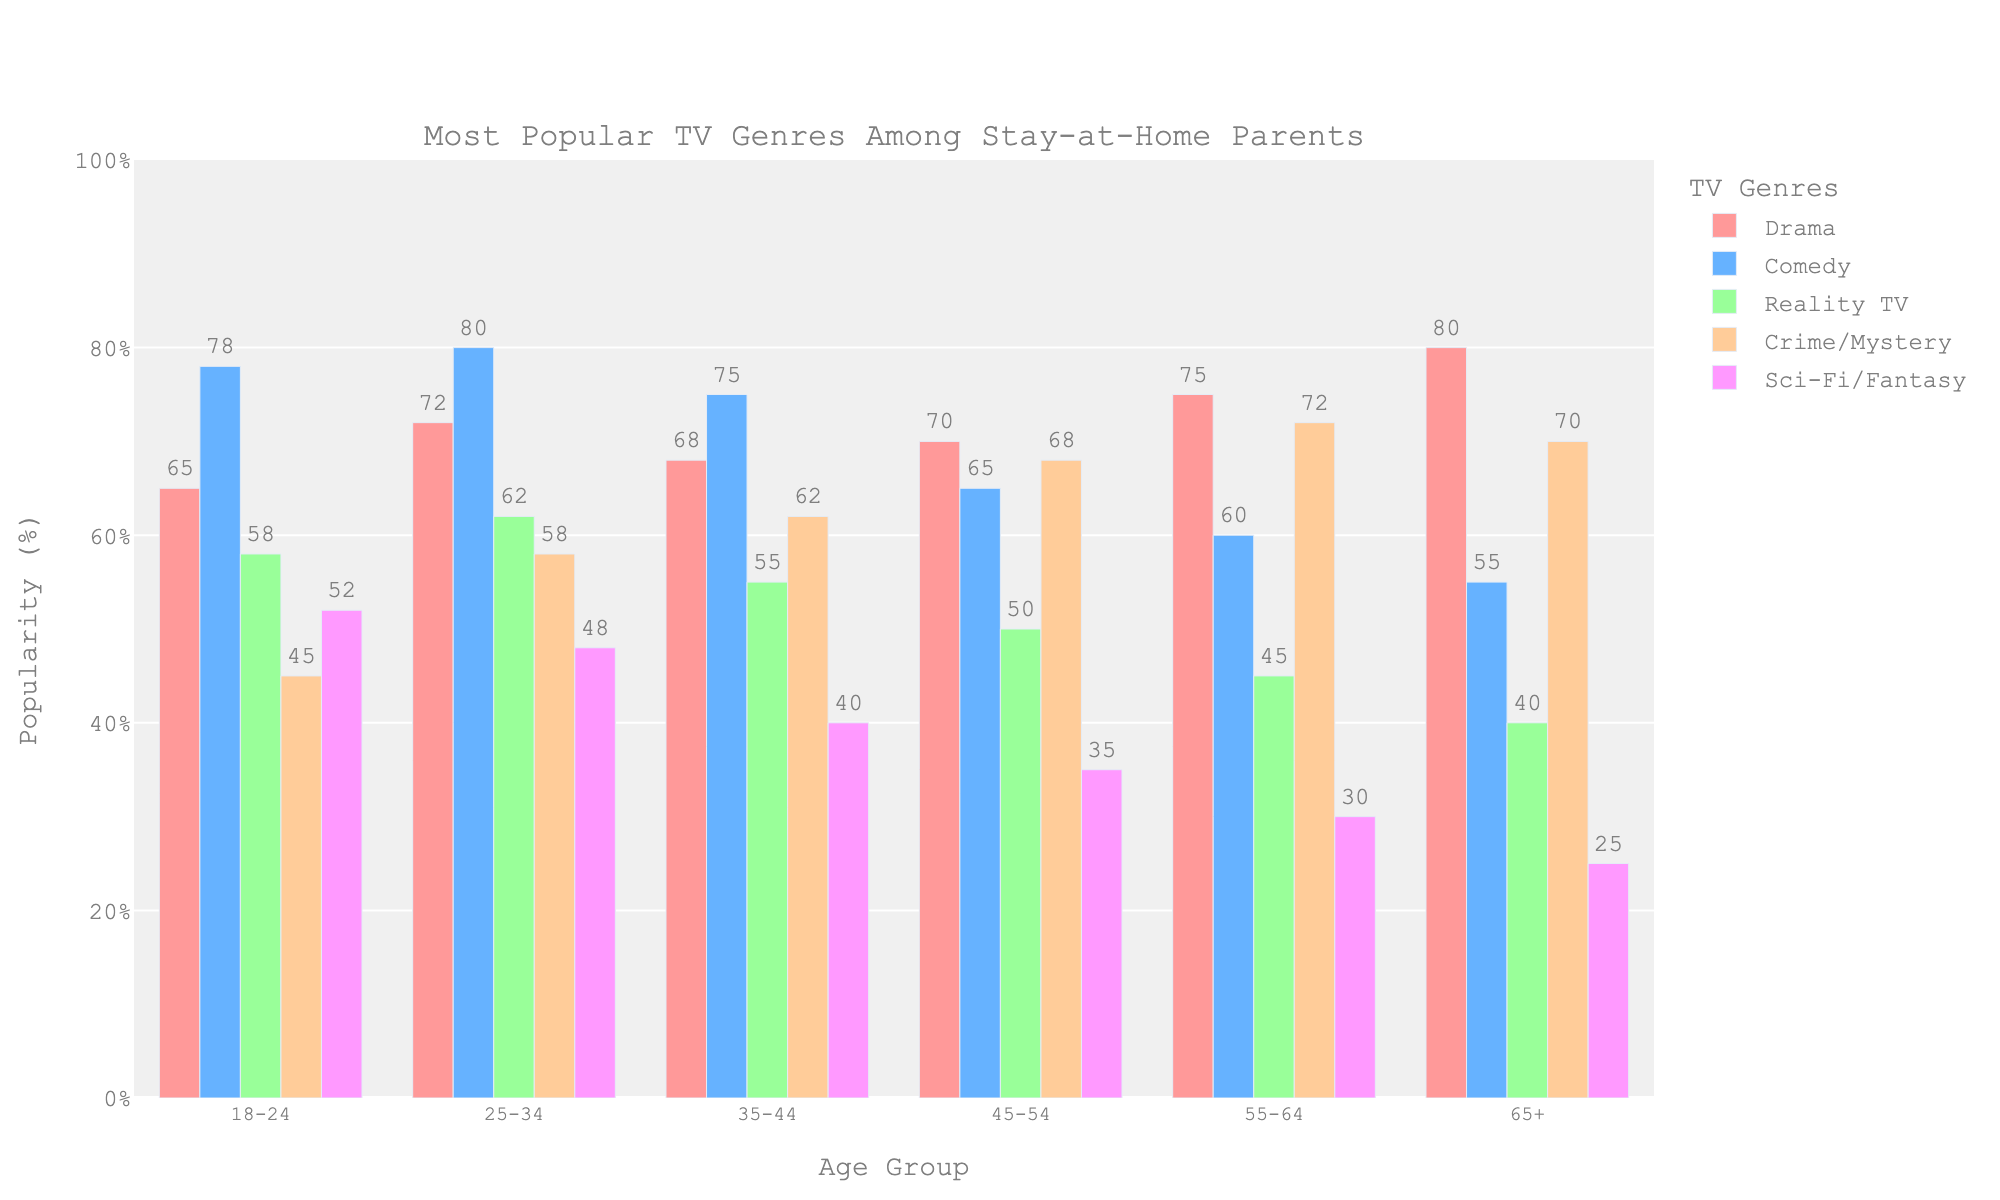What's the most popular TV genre among stay-at-home parents aged 18-24? By looking at the bar heights for the age group 18-24, the highest bar belongs to Comedy with a value of 78
Answer: Comedy Which age group prefers Sci-Fi/Fantasy the most? By comparing the bar heights for Sci-Fi/Fantasy across all age groups, the highest bar is for the 18-24 age group with a value of 52
Answer: 18-24 What's the difference in the popularity of Reality TV between the 25-34 and 45-54 age groups? The bar for Reality TV in the 25-34 age group is at 62, and in the 45-54 age group it is at 50. The difference is 62 - 50 = 12
Answer: 12 Which TV genre has the lowest popularity among stay-at-home parents aged 65+? By checking the bar heights for all genres in the 65+ age group, the lowest value is for Sci-Fi/Fantasy at 25
Answer: Sci-Fi/Fantasy What is the average popularity of Drama for the age groups 18-24, 25-34, and 35-44? The values for Drama in these age groups are 65 (18-24), 72 (25-34), and 68 (35-44). Summing them up gives 65 + 72 + 68 = 205, and the average is 205 / 3 = 68.33
Answer: 68.33 Which age group has the highest overall preference for Crime/Mystery? By comparing the bar heights for Crime/Mystery across all age groups, the highest value is observed in the 55-64 age group at 72
Answer: 55-64 Is Comedy more popular than Drama in the 25-34 age group? The bar for Comedy in the 25-34 age group is at 80, while the bar for Drama is at 72. Since 80 is greater than 72, Comedy is more popular
Answer: Yes What is the total popularity percentage for all genres in the 45-54 age group? The values for the 45-54 age group are Drama (70), Comedy (65), Reality TV (50), Crime/Mystery (68), and Sci-Fi/Fantasy (35). The total is 70 + 65 + 50 + 68 + 35 = 288
Answer: 288 In which age group is Reality TV the least popular? By comparing the bar heights for Reality TV across all age groups, the lowest value is observed in the 65+ age group at 40
Answer: 65+ How much more popular is Sci-Fi/Fantasy among stay-at-home parents aged 18-24 compared to the 65+ age group? The value for Sci-Fi/Fantasy in the 18-24 age group is 52, and in the 65+ age group it is 25. The difference is 52 - 25 = 27
Answer: 27 